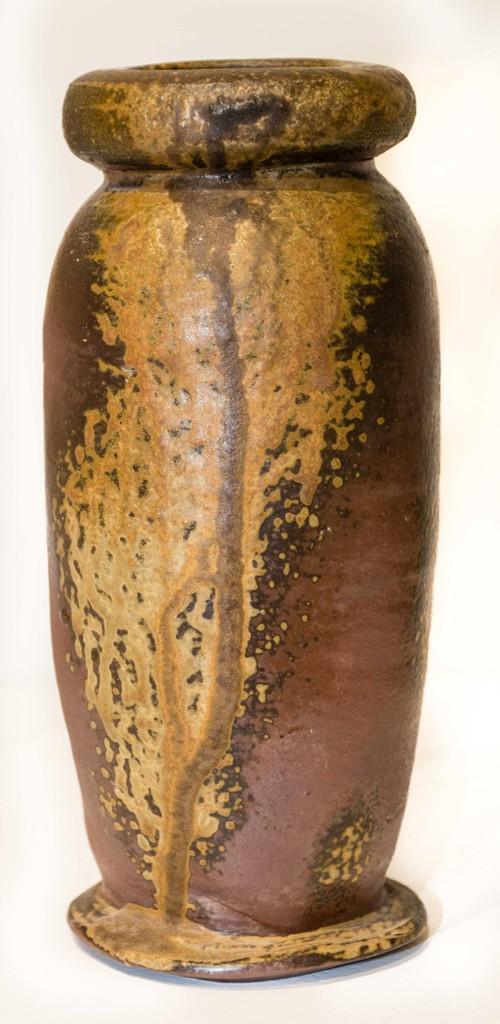How would you summarize this image in a sentence or two? In this image we can see there is a pot. 